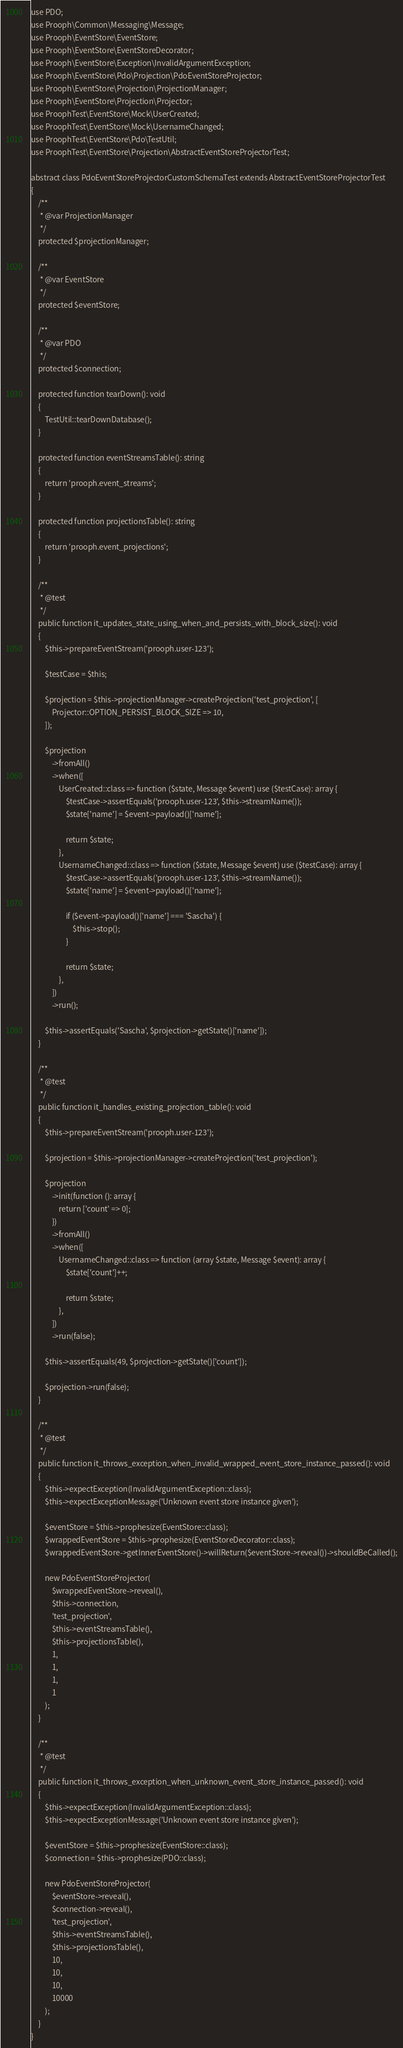Convert code to text. <code><loc_0><loc_0><loc_500><loc_500><_PHP_>use PDO;
use Prooph\Common\Messaging\Message;
use Prooph\EventStore\EventStore;
use Prooph\EventStore\EventStoreDecorator;
use Prooph\EventStore\Exception\InvalidArgumentException;
use Prooph\EventStore\Pdo\Projection\PdoEventStoreProjector;
use Prooph\EventStore\Projection\ProjectionManager;
use Prooph\EventStore\Projection\Projector;
use ProophTest\EventStore\Mock\UserCreated;
use ProophTest\EventStore\Mock\UsernameChanged;
use ProophTest\EventStore\Pdo\TestUtil;
use ProophTest\EventStore\Projection\AbstractEventStoreProjectorTest;

abstract class PdoEventStoreProjectorCustomSchemaTest extends AbstractEventStoreProjectorTest
{
    /**
     * @var ProjectionManager
     */
    protected $projectionManager;

    /**
     * @var EventStore
     */
    protected $eventStore;

    /**
     * @var PDO
     */
    protected $connection;

    protected function tearDown(): void
    {
        TestUtil::tearDownDatabase();
    }

    protected function eventStreamsTable(): string
    {
        return 'prooph.event_streams';
    }

    protected function projectionsTable(): string
    {
        return 'prooph.event_projections';
    }

    /**
     * @test
     */
    public function it_updates_state_using_when_and_persists_with_block_size(): void
    {
        $this->prepareEventStream('prooph.user-123');

        $testCase = $this;

        $projection = $this->projectionManager->createProjection('test_projection', [
            Projector::OPTION_PERSIST_BLOCK_SIZE => 10,
        ]);

        $projection
            ->fromAll()
            ->when([
                UserCreated::class => function ($state, Message $event) use ($testCase): array {
                    $testCase->assertEquals('prooph.user-123', $this->streamName());
                    $state['name'] = $event->payload()['name'];

                    return $state;
                },
                UsernameChanged::class => function ($state, Message $event) use ($testCase): array {
                    $testCase->assertEquals('prooph.user-123', $this->streamName());
                    $state['name'] = $event->payload()['name'];

                    if ($event->payload()['name'] === 'Sascha') {
                        $this->stop();
                    }

                    return $state;
                },
            ])
            ->run();

        $this->assertEquals('Sascha', $projection->getState()['name']);
    }

    /**
     * @test
     */
    public function it_handles_existing_projection_table(): void
    {
        $this->prepareEventStream('prooph.user-123');

        $projection = $this->projectionManager->createProjection('test_projection');

        $projection
            ->init(function (): array {
                return ['count' => 0];
            })
            ->fromAll()
            ->when([
                UsernameChanged::class => function (array $state, Message $event): array {
                    $state['count']++;

                    return $state;
                },
            ])
            ->run(false);

        $this->assertEquals(49, $projection->getState()['count']);

        $projection->run(false);
    }

    /**
     * @test
     */
    public function it_throws_exception_when_invalid_wrapped_event_store_instance_passed(): void
    {
        $this->expectException(InvalidArgumentException::class);
        $this->expectExceptionMessage('Unknown event store instance given');

        $eventStore = $this->prophesize(EventStore::class);
        $wrappedEventStore = $this->prophesize(EventStoreDecorator::class);
        $wrappedEventStore->getInnerEventStore()->willReturn($eventStore->reveal())->shouldBeCalled();

        new PdoEventStoreProjector(
            $wrappedEventStore->reveal(),
            $this->connection,
            'test_projection',
            $this->eventStreamsTable(),
            $this->projectionsTable(),
            1,
            1,
            1,
            1
        );
    }

    /**
     * @test
     */
    public function it_throws_exception_when_unknown_event_store_instance_passed(): void
    {
        $this->expectException(InvalidArgumentException::class);
        $this->expectExceptionMessage('Unknown event store instance given');

        $eventStore = $this->prophesize(EventStore::class);
        $connection = $this->prophesize(PDO::class);

        new PdoEventStoreProjector(
            $eventStore->reveal(),
            $connection->reveal(),
            'test_projection',
            $this->eventStreamsTable(),
            $this->projectionsTable(),
            10,
            10,
            10,
            10000
        );
    }
}
</code> 